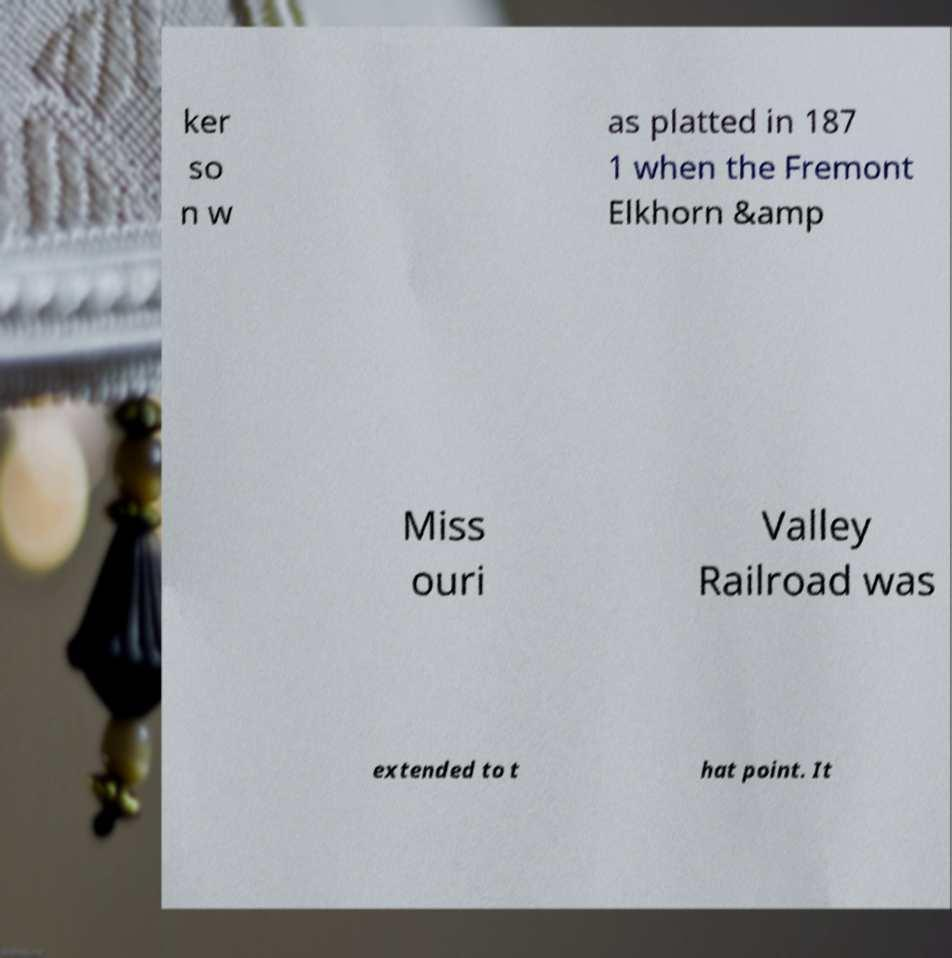Could you extract and type out the text from this image? ker so n w as platted in 187 1 when the Fremont Elkhorn &amp Miss ouri Valley Railroad was extended to t hat point. It 